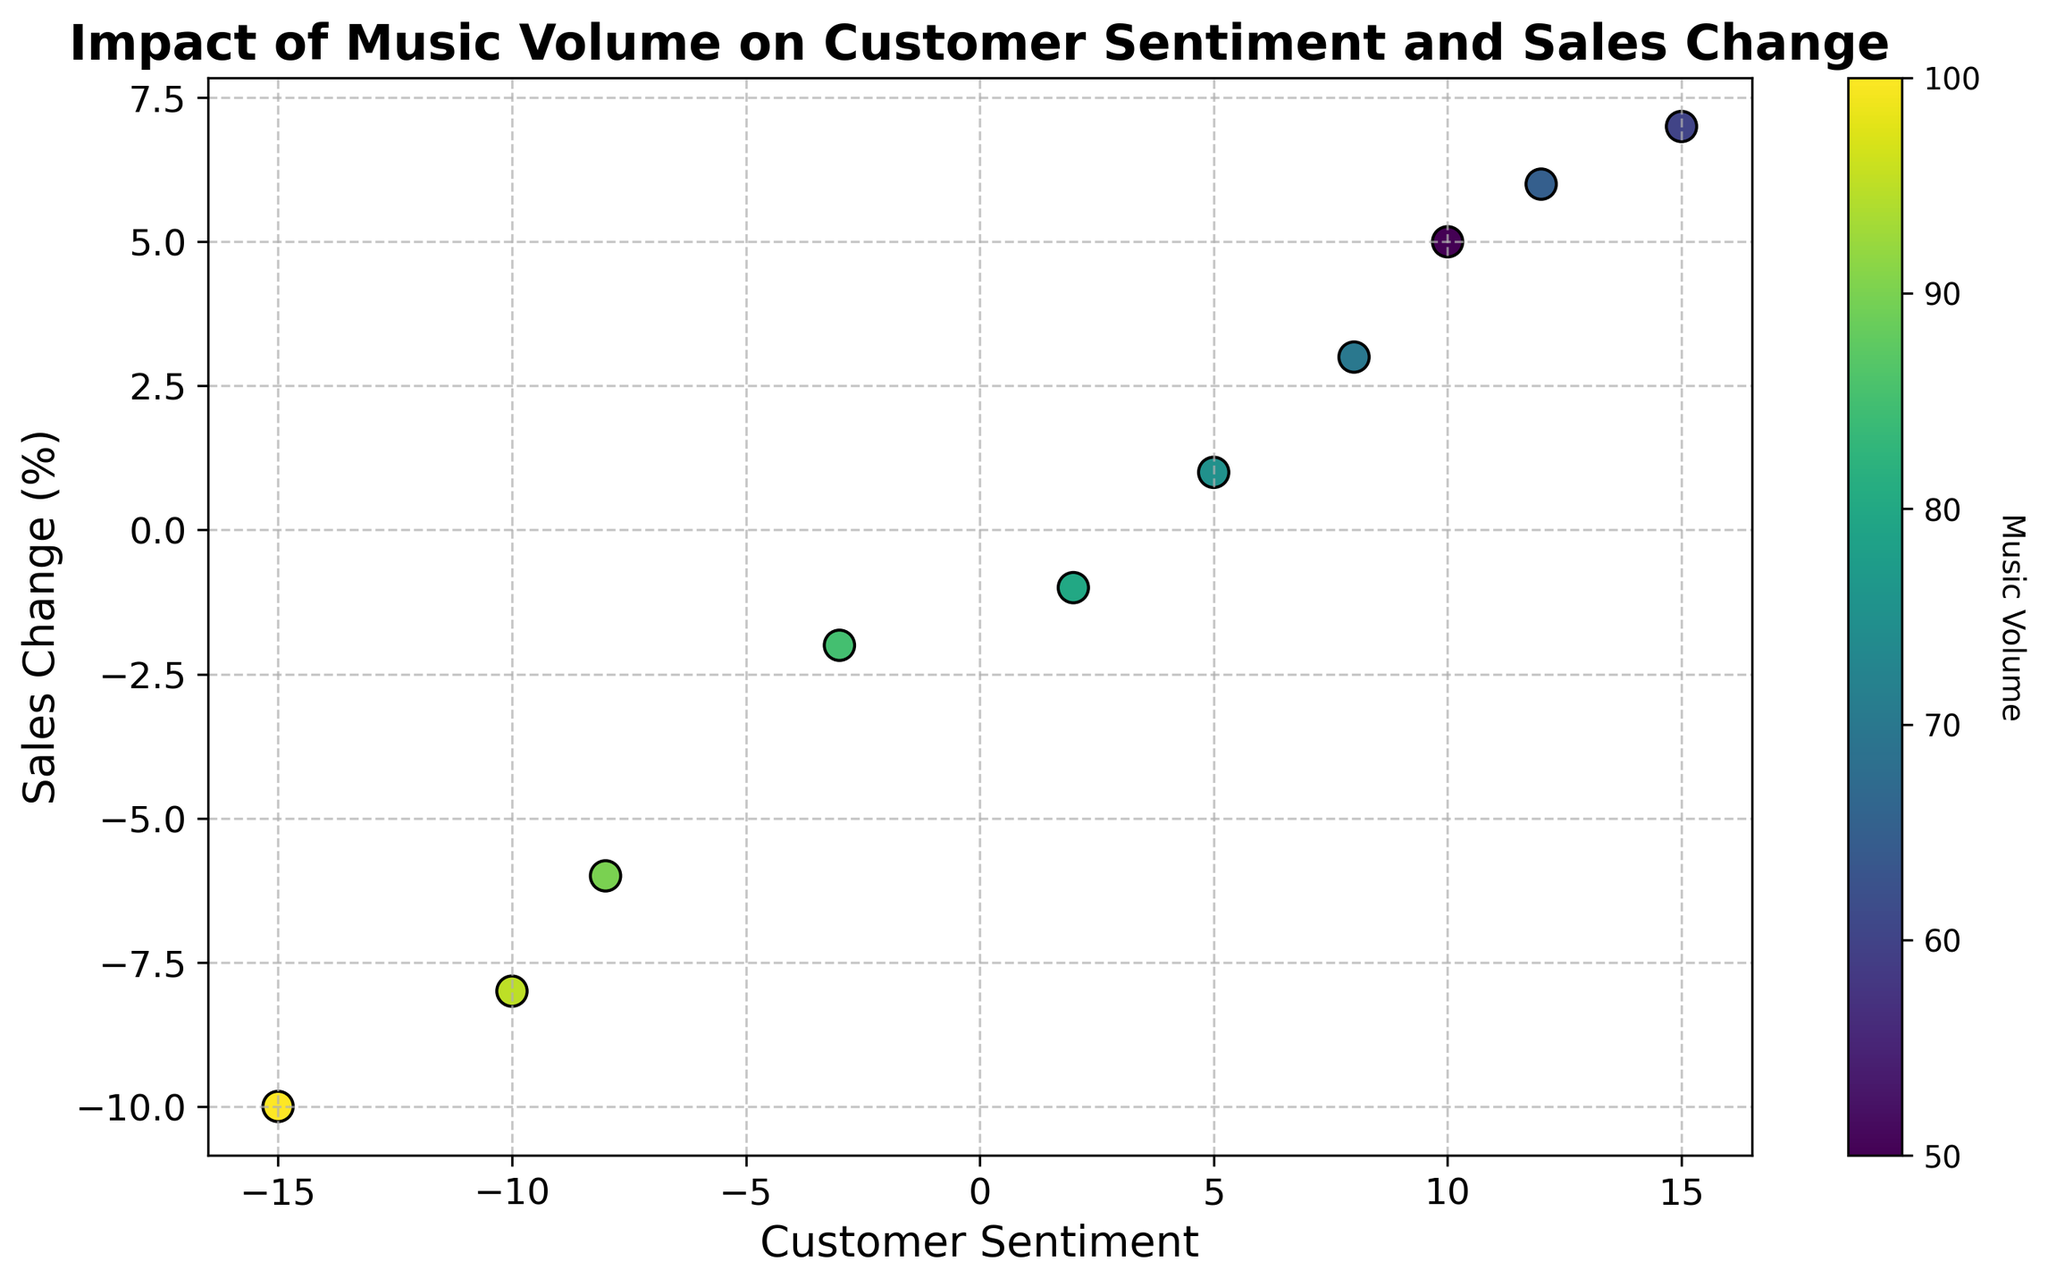What is the general trend between customer sentiment and sales change as music volume increases? The plot shows that as music volume increases, there is a negative trend between customer sentiment and sales change. At higher music volumes, both customer sentiment and sales change tend to decrease.
Answer: Negative trend Which music volume corresponds to the lowest customer sentiment observed in the plot? By looking at the color bar and the scatter plot, the lowest customer sentiment (-15) is recorded at the highest music volume (100).
Answer: 100 At what music volume is the customer sentiment equal to zero? The plot does not show a data point where customer sentiment is exactly zero; all the displayed customer sentiment values are either positive or negative. Thus, there is no music volume where customer sentiment is zero.
Answer: None Compare the sales changes when music volumes are 60 and 90. Which volume results in a higher sales change? The scatter plot shows that at a music volume of 60, the sales change is 7%, whereas at 90, the sales change is -6%. Thus, a music volume of 60 results in a higher sales change.
Answer: 60 What is the customer sentiment when sales change reaches its maximum observed value? By finding the highest sales change value on the y-axis (7%) and referring to the associated data point, the corresponding customer sentiment is 15.
Answer: 15 Calculate the difference in sales change between the highest and lowest customer sentiment values. The highest customer sentiment is 15 with a sales change of 7%, and the lowest is -15 with a sales change of -10%. The difference is calculated as 7 - (-10) = 17%.
Answer: 17% What music volume shows the closest relationship between customer sentiment and sales change relative to other points in the plot? The music volume 60 shows a relatively direct and strong positive relationship between customer sentiment (15) and sales change (7%) compared to other points.
Answer: 60 Identify the data point with the smallest absolute difference between customer sentiment and sales change. What is the music volume for this point? By assessing the differences between the values, the data point with music volume 75 shows a customer sentiment of 5 and a sales change of 1, resulting in an absolute difference of 4.
Answer: 75 What is the average customer sentiment at music volumes of 65 and 70? The customer sentiment values are 12 and 8 at volumes 65 and 70, respectively. The average is calculated as (12 + 8) / 2 = 10.
Answer: 10 